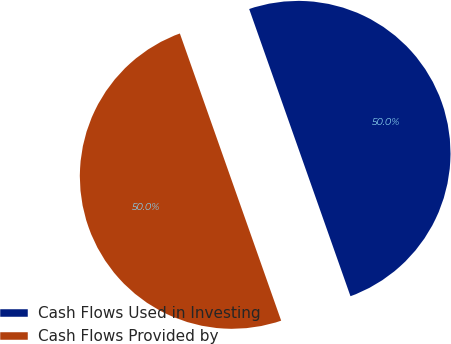<chart> <loc_0><loc_0><loc_500><loc_500><pie_chart><fcel>Cash Flows Used in Investing<fcel>Cash Flows Provided by<nl><fcel>50.0%<fcel>50.0%<nl></chart> 